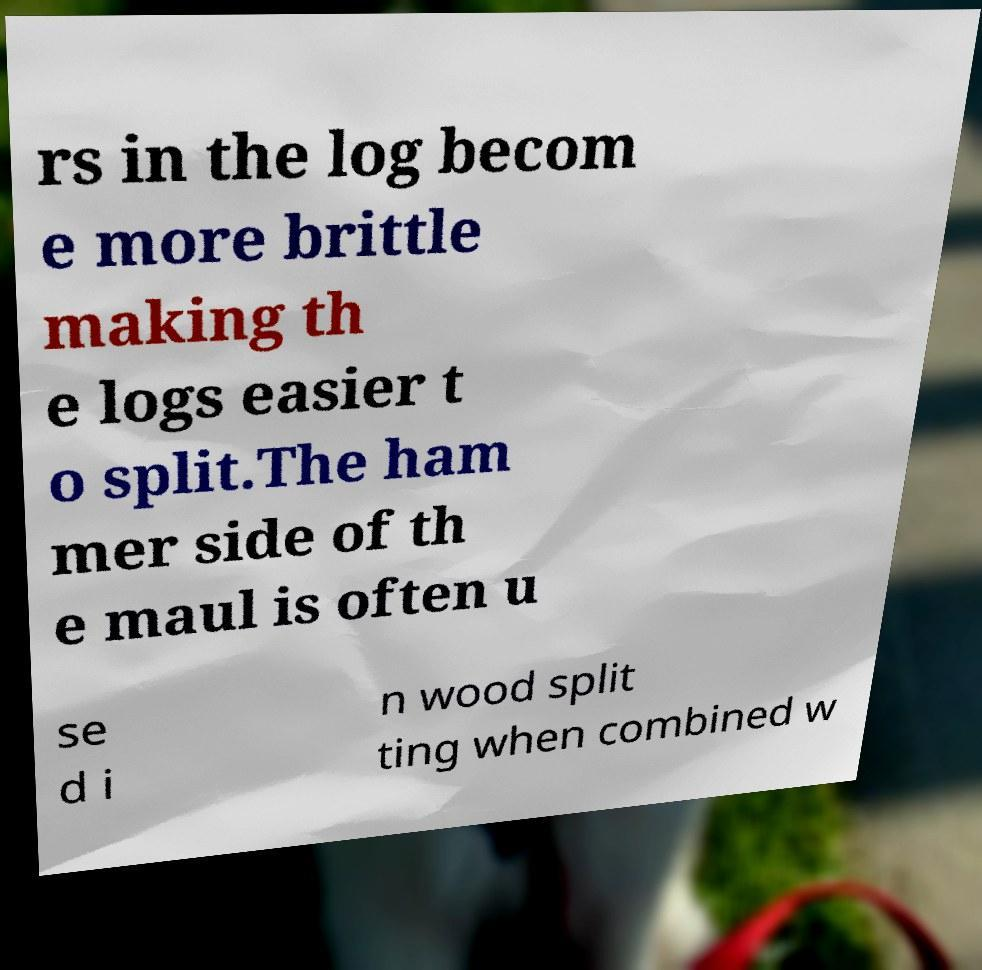Please identify and transcribe the text found in this image. rs in the log becom e more brittle making th e logs easier t o split.The ham mer side of th e maul is often u se d i n wood split ting when combined w 